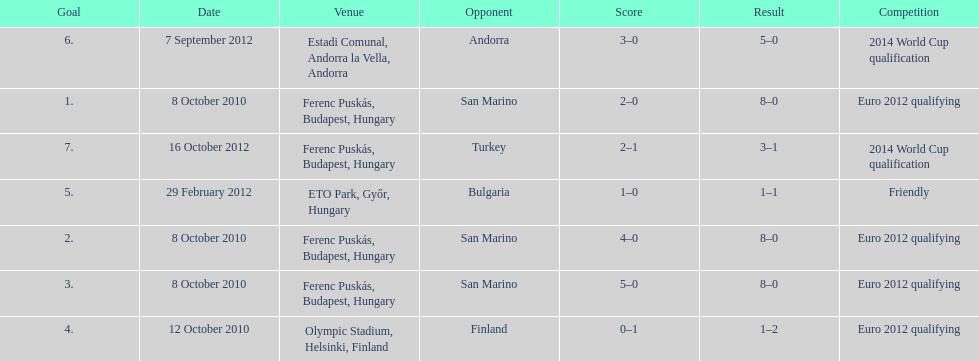What is the total number of international goals ádám szalai has made? 7. 